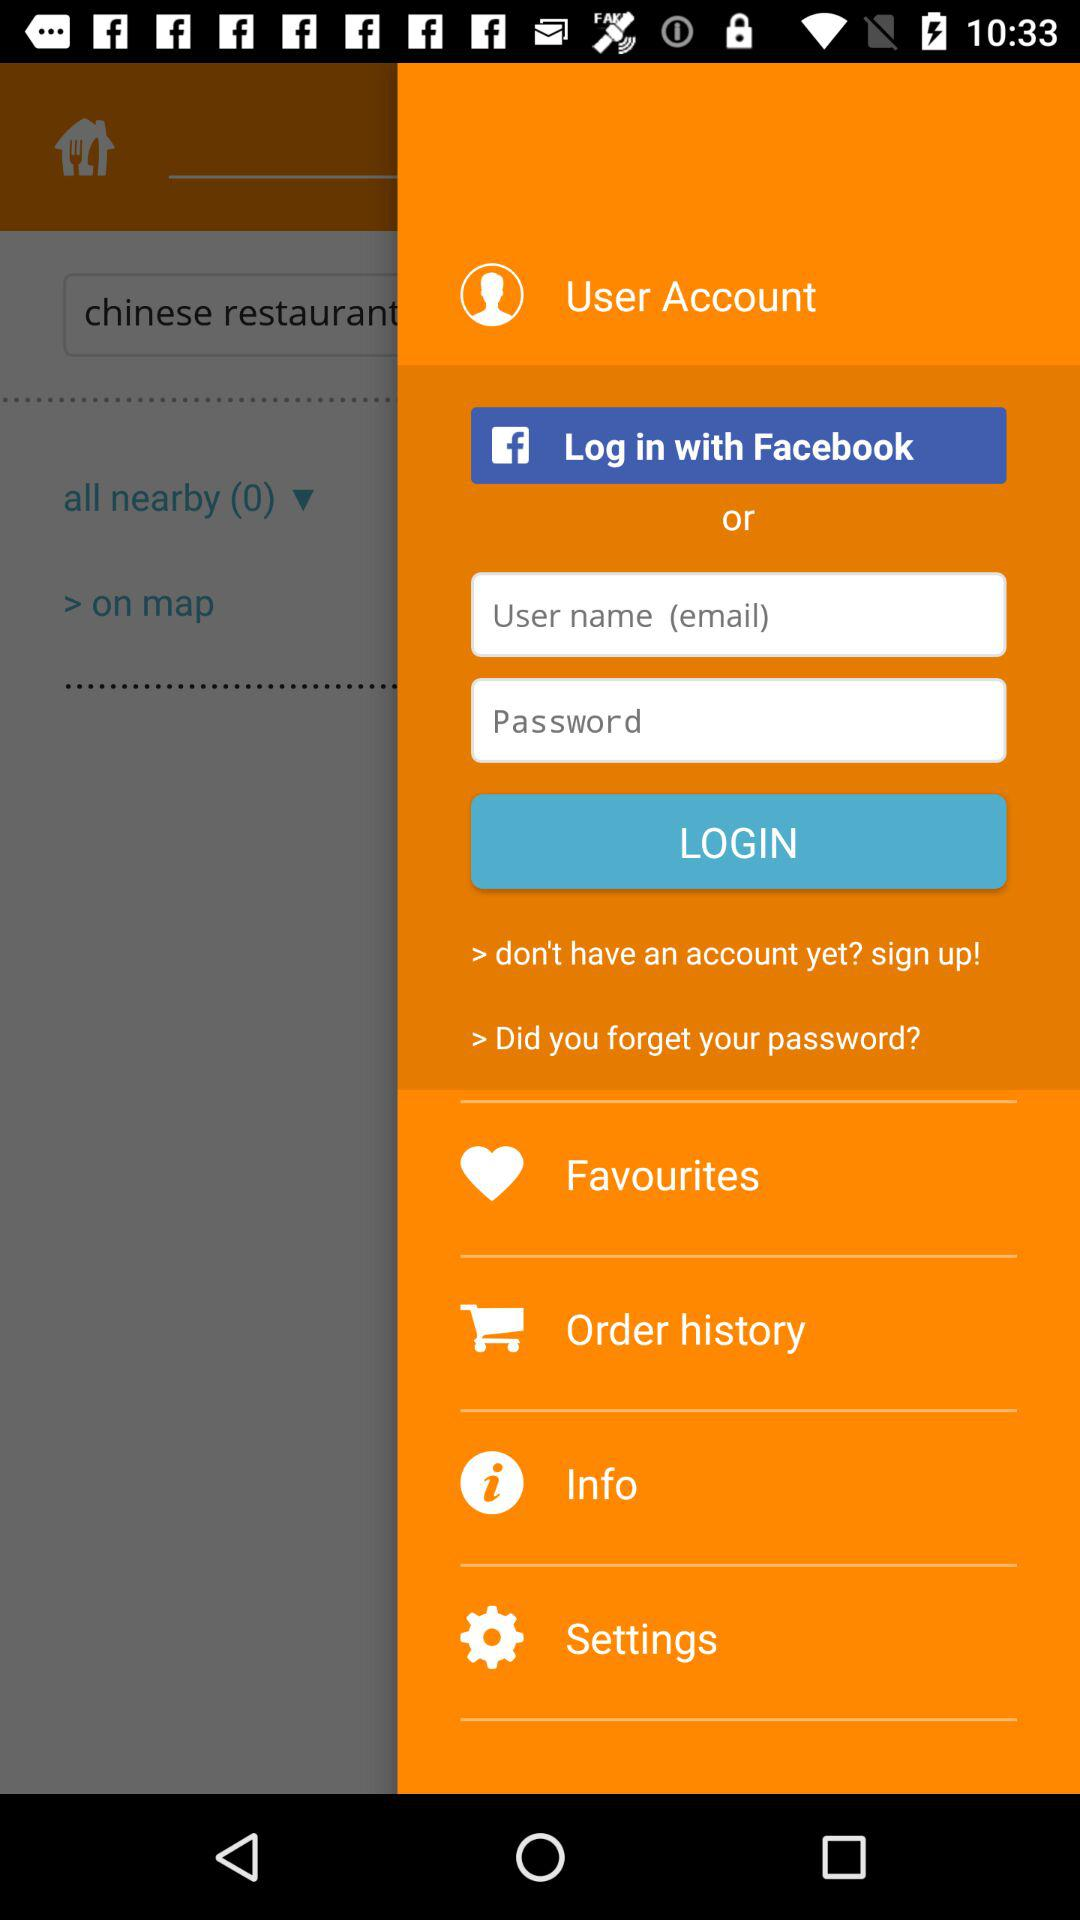How many login options are available?
Answer the question using a single word or phrase. 2 